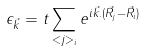<formula> <loc_0><loc_0><loc_500><loc_500>\epsilon _ { \vec { k } } = t \sum _ { < j > _ { i } } e ^ { i \vec { k } . ( \vec { R } _ { j } - \vec { R } _ { i } ) }</formula> 